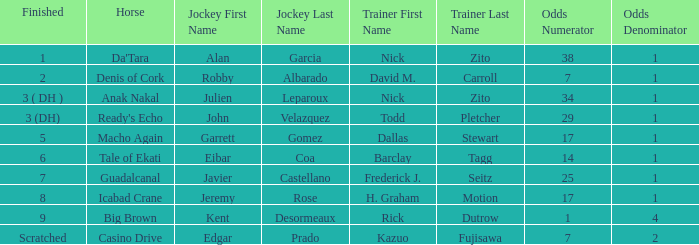Who is the equestrian for guadalcanal? Javier Castellano. 